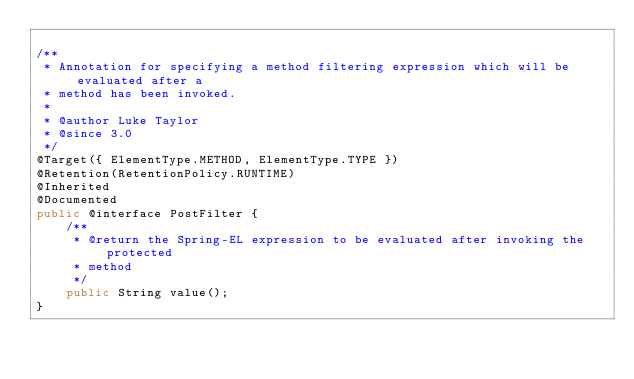Convert code to text. <code><loc_0><loc_0><loc_500><loc_500><_Java_>
/**
 * Annotation for specifying a method filtering expression which will be evaluated after a
 * method has been invoked.
 *
 * @author Luke Taylor
 * @since 3.0
 */
@Target({ ElementType.METHOD, ElementType.TYPE })
@Retention(RetentionPolicy.RUNTIME)
@Inherited
@Documented
public @interface PostFilter {
	/**
	 * @return the Spring-EL expression to be evaluated after invoking the protected
	 * method
	 */
	public String value();
}
</code> 